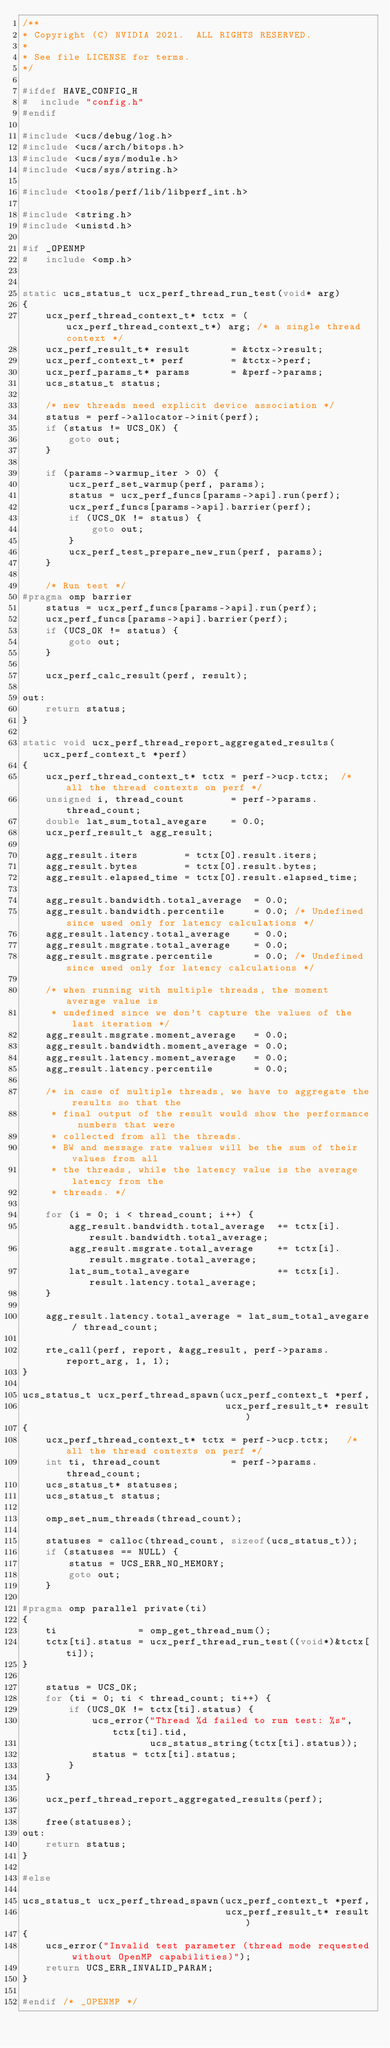Convert code to text. <code><loc_0><loc_0><loc_500><loc_500><_C_>/**
* Copyright (C) NVIDIA 2021.  ALL RIGHTS RESERVED.
*
* See file LICENSE for terms.
*/

#ifdef HAVE_CONFIG_H
#  include "config.h"
#endif

#include <ucs/debug/log.h>
#include <ucs/arch/bitops.h>
#include <ucs/sys/module.h>
#include <ucs/sys/string.h>

#include <tools/perf/lib/libperf_int.h>

#include <string.h>
#include <unistd.h>

#if _OPENMP
#   include <omp.h>


static ucs_status_t ucx_perf_thread_run_test(void* arg)
{
    ucx_perf_thread_context_t* tctx = (ucx_perf_thread_context_t*) arg; /* a single thread context */
    ucx_perf_result_t* result       = &tctx->result;
    ucx_perf_context_t* perf        = &tctx->perf;
    ucx_perf_params_t* params       = &perf->params;
    ucs_status_t status;

    /* new threads need explicit device association */
    status = perf->allocator->init(perf);
    if (status != UCS_OK) {
        goto out;
    }

    if (params->warmup_iter > 0) {
        ucx_perf_set_warmup(perf, params);
        status = ucx_perf_funcs[params->api].run(perf);
        ucx_perf_funcs[params->api].barrier(perf);
        if (UCS_OK != status) {
            goto out;
        }
        ucx_perf_test_prepare_new_run(perf, params);
    }

    /* Run test */
#pragma omp barrier
    status = ucx_perf_funcs[params->api].run(perf);
    ucx_perf_funcs[params->api].barrier(perf);
    if (UCS_OK != status) {
        goto out;
    }

    ucx_perf_calc_result(perf, result);

out:
    return status;
}

static void ucx_perf_thread_report_aggregated_results(ucx_perf_context_t *perf)
{
    ucx_perf_thread_context_t* tctx = perf->ucp.tctx;  /* all the thread contexts on perf */
    unsigned i, thread_count        = perf->params.thread_count;
    double lat_sum_total_avegare    = 0.0;
    ucx_perf_result_t agg_result;

    agg_result.iters        = tctx[0].result.iters;
    agg_result.bytes        = tctx[0].result.bytes;
    agg_result.elapsed_time = tctx[0].result.elapsed_time;

    agg_result.bandwidth.total_average  = 0.0;
    agg_result.bandwidth.percentile     = 0.0; /* Undefined since used only for latency calculations */
    agg_result.latency.total_average    = 0.0;
    agg_result.msgrate.total_average    = 0.0;
    agg_result.msgrate.percentile       = 0.0; /* Undefined since used only for latency calculations */

    /* when running with multiple threads, the moment average value is
     * undefined since we don't capture the values of the last iteration */
    agg_result.msgrate.moment_average   = 0.0;
    agg_result.bandwidth.moment_average = 0.0;
    agg_result.latency.moment_average   = 0.0;
    agg_result.latency.percentile       = 0.0;

    /* in case of multiple threads, we have to aggregate the results so that the
     * final output of the result would show the performance numbers that were
     * collected from all the threads.
     * BW and message rate values will be the sum of their values from all
     * the threads, while the latency value is the average latency from the
     * threads. */

    for (i = 0; i < thread_count; i++) {
        agg_result.bandwidth.total_average  += tctx[i].result.bandwidth.total_average;
        agg_result.msgrate.total_average    += tctx[i].result.msgrate.total_average;
        lat_sum_total_avegare               += tctx[i].result.latency.total_average;
    }

    agg_result.latency.total_average = lat_sum_total_avegare / thread_count;

    rte_call(perf, report, &agg_result, perf->params.report_arg, 1, 1);
}

ucs_status_t ucx_perf_thread_spawn(ucx_perf_context_t *perf,
                                   ucx_perf_result_t* result)
{
    ucx_perf_thread_context_t* tctx = perf->ucp.tctx;   /* all the thread contexts on perf */
    int ti, thread_count            = perf->params.thread_count;
    ucs_status_t* statuses;
    ucs_status_t status;

    omp_set_num_threads(thread_count);

    statuses = calloc(thread_count, sizeof(ucs_status_t));
    if (statuses == NULL) {
        status = UCS_ERR_NO_MEMORY;
        goto out;
    }

#pragma omp parallel private(ti)
{
    ti              = omp_get_thread_num();
    tctx[ti].status = ucx_perf_thread_run_test((void*)&tctx[ti]);
}

    status = UCS_OK;
    for (ti = 0; ti < thread_count; ti++) {
        if (UCS_OK != tctx[ti].status) {
            ucs_error("Thread %d failed to run test: %s", tctx[ti].tid,
                      ucs_status_string(tctx[ti].status));
            status = tctx[ti].status;
        }
    }

    ucx_perf_thread_report_aggregated_results(perf);

    free(statuses);
out:
    return status;
}

#else

ucs_status_t ucx_perf_thread_spawn(ucx_perf_context_t *perf,
                                   ucx_perf_result_t* result)
{
    ucs_error("Invalid test parameter (thread mode requested without OpenMP capabilities)");
    return UCS_ERR_INVALID_PARAM;
}

#endif /* _OPENMP */
</code> 